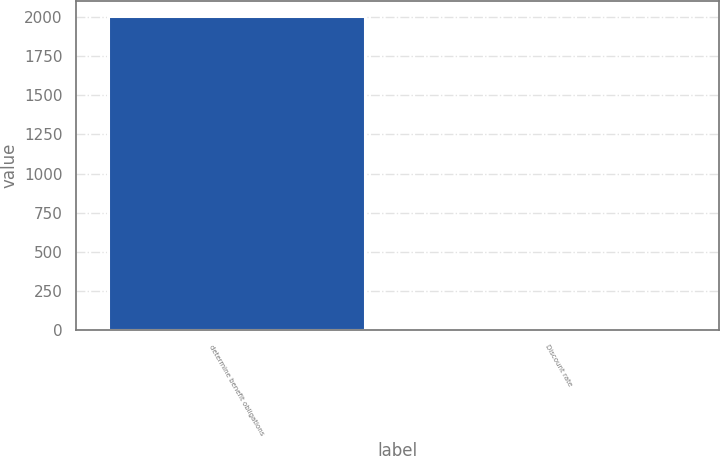Convert chart. <chart><loc_0><loc_0><loc_500><loc_500><bar_chart><fcel>determine benefit obligations<fcel>Discount rate<nl><fcel>2003<fcel>6.25<nl></chart> 